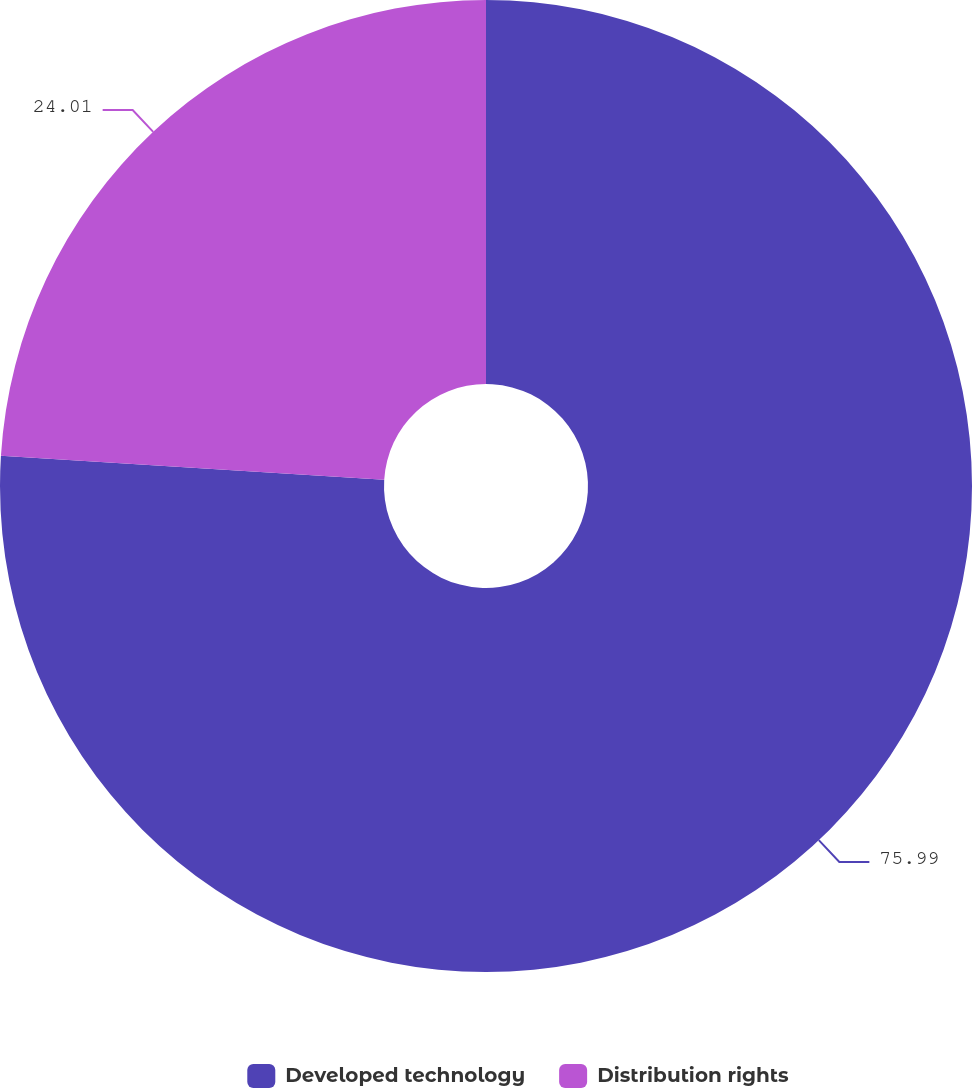Convert chart to OTSL. <chart><loc_0><loc_0><loc_500><loc_500><pie_chart><fcel>Developed technology<fcel>Distribution rights<nl><fcel>75.99%<fcel>24.01%<nl></chart> 